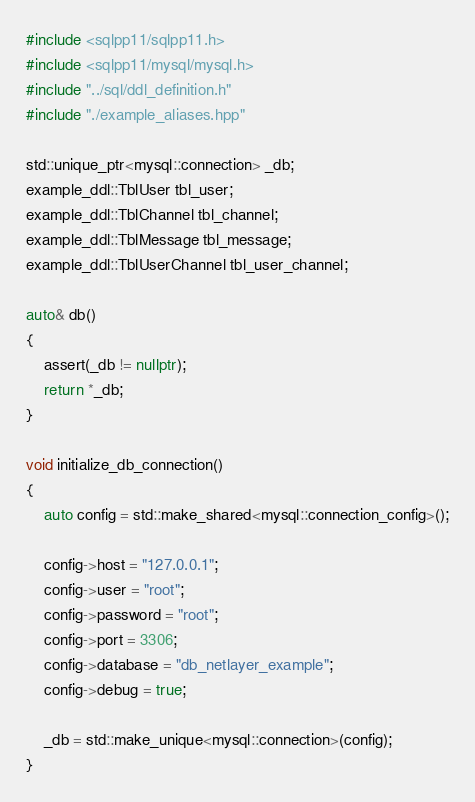<code> <loc_0><loc_0><loc_500><loc_500><_C++_>#include <sqlpp11/sqlpp11.h>
#include <sqlpp11/mysql/mysql.h>
#include "../sql/ddl_definition.h"
#include "./example_aliases.hpp"

std::unique_ptr<mysql::connection> _db;
example_ddl::TblUser tbl_user;
example_ddl::TblChannel tbl_channel;
example_ddl::TblMessage tbl_message;
example_ddl::TblUserChannel tbl_user_channel;

auto& db()
{
    assert(_db != nullptr);
    return *_db;
}

void initialize_db_connection()
{
    auto config = std::make_shared<mysql::connection_config>();

    config->host = "127.0.0.1";
    config->user = "root";
    config->password = "root";
    config->port = 3306;
    config->database = "db_netlayer_example";
    config->debug = true;

    _db = std::make_unique<mysql::connection>(config);
}
</code> 